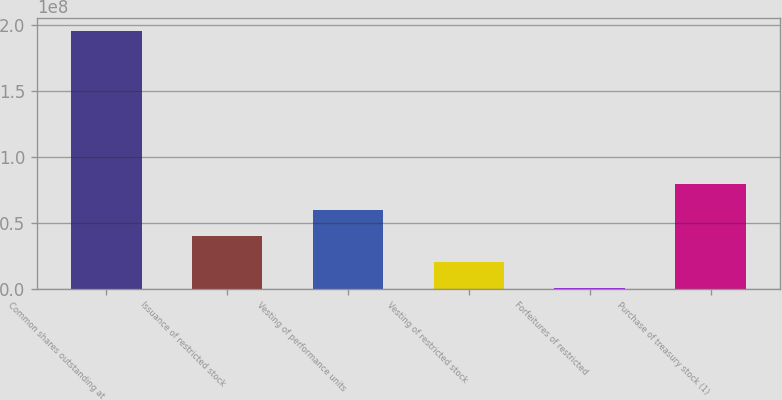Convert chart. <chart><loc_0><loc_0><loc_500><loc_500><bar_chart><fcel>Common shares outstanding at<fcel>Issuance of restricted stock<fcel>Vesting of performance units<fcel>Vesting of restricted stock<fcel>Forfeitures of restricted<fcel>Purchase of treasury stock (1)<nl><fcel>1.96086e+08<fcel>3.9827e+07<fcel>5.97024e+07<fcel>1.99515e+07<fcel>76107<fcel>7.95778e+07<nl></chart> 